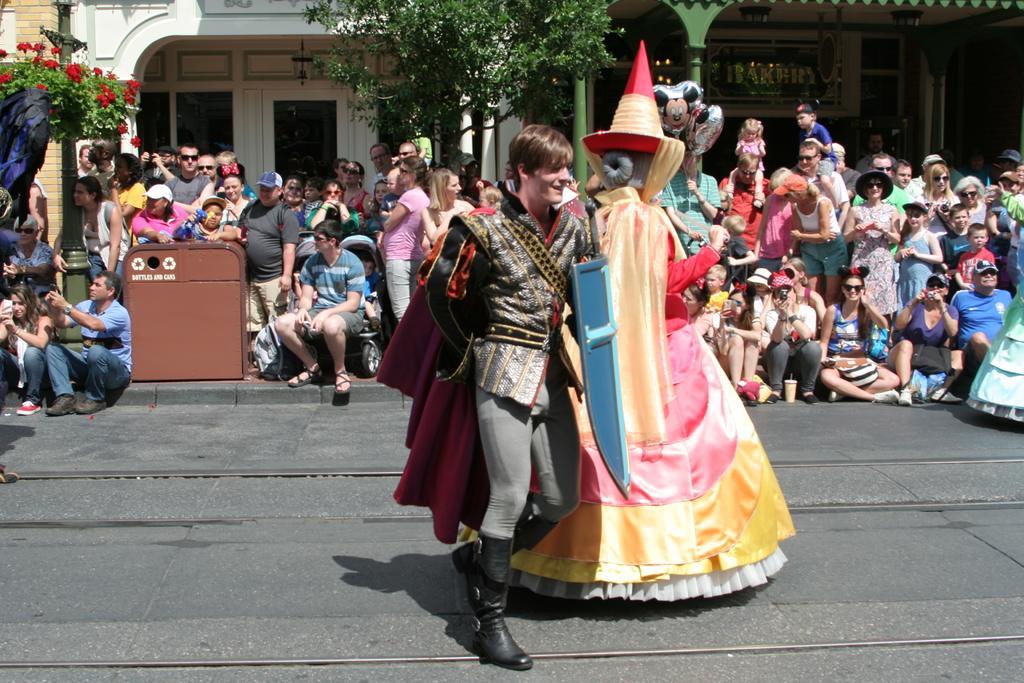Please provide a concise description of this image. In this image I can see a group of people wearing different color dresses. In front I can see two people are wearing different costumes. Back I can see buildings,doors,windows,trees and poles. 